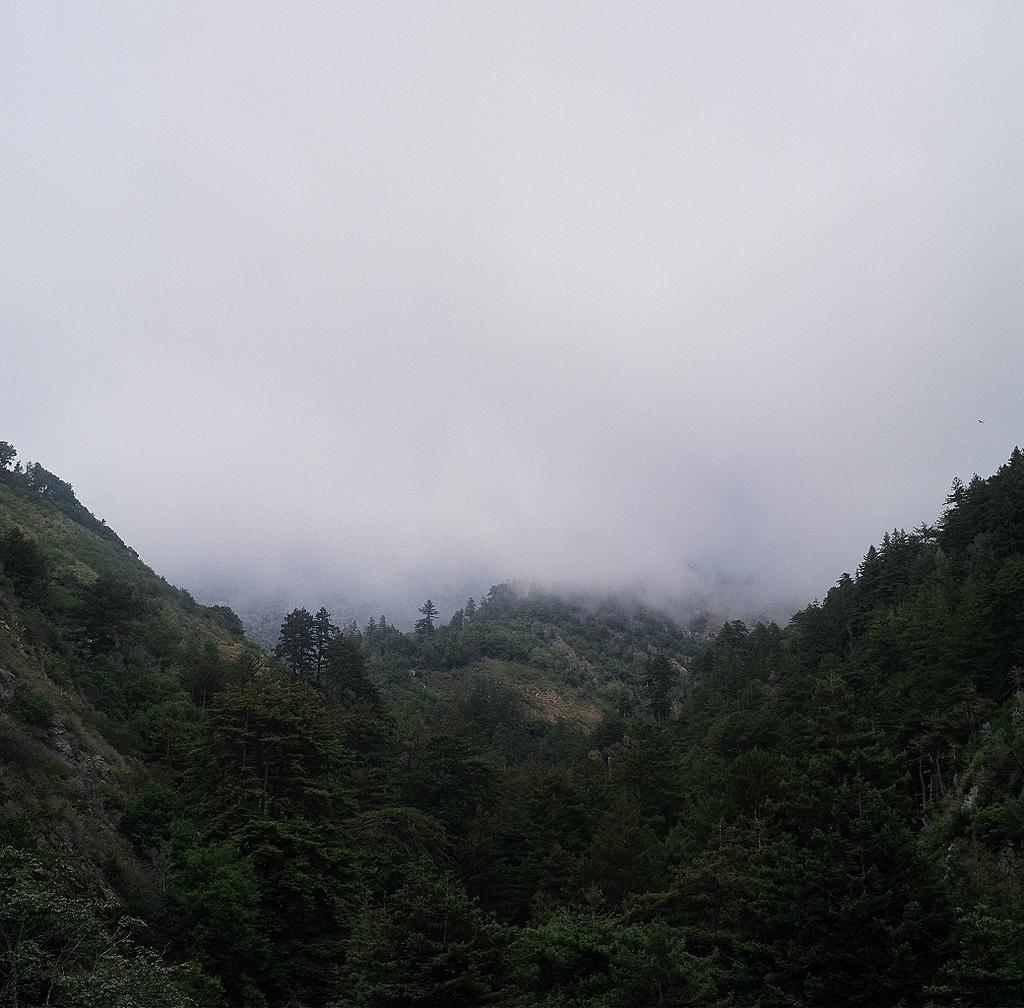What type of landscape is depicted in the image? The image features hills. What other natural elements can be seen in the image? There are trees in the image. What atmospheric phenomenon is visible in the image? There is a smoky cloud in the image. What time of year is it in the image, based on the presence of bells? There are no bells present in the image, so it is not possible to determine the time of year based on this information. 